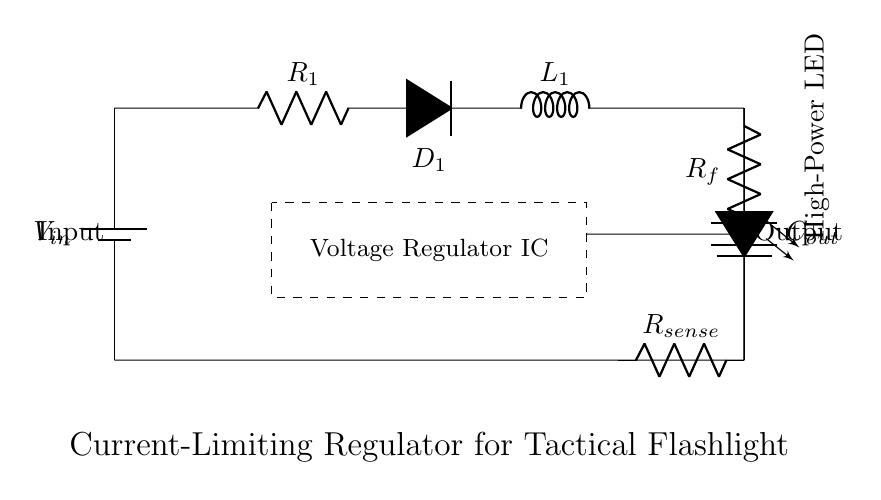What type of voltage regulator is shown in the circuit? The circuit features a current-limiting voltage regulator, which is specifically designed to maintain a constant output current regardless of fluctuations in input voltage or load resistance. This is crucial for applications like tactical flashlights that require stable brightness.
Answer: current-limiting voltage regulator What is the purpose of the current sense resistor in this circuit? The current sense resistor measures the output current flowing to the load. Its value is monitored by the voltage regulator to adjust the output current and prevent overcurrent conditions that could damage the LED load or reduce its lifespan.
Answer: measures output current What component is responsible for converting varying voltage to a steady output? The voltage regulator IC clamps the output voltage at a desired level by adjusting the control signal based on feedback from the current sense resistor. This ensures the output remains stable for the LED load despite changes in input voltage.
Answer: voltage regulator IC How many resistors are present in the circuit? There are three resistors in the circuit: R1 (series resistor), Rf (feedback resistor), and Rsense (current sense resistor). Each plays a critical role in controlling the current and feedback for the regulator.
Answer: three What happens to the output if the input voltage increases? As the input voltage increases, the voltage regulator IC adjusts the output to maintain a constant output current, protecting the high-power LED load from damage due to overcurrent. This action is achieved through feedback from the current sense resistor.
Answer: constant output current What type of LED is used in this circuit? The circuit uses a high-power LED specifically designed for application in tactical flashlights. This type is chosen for its efficiency and high light output, which is crucial for visibility in low-light situations.
Answer: high-power LED 